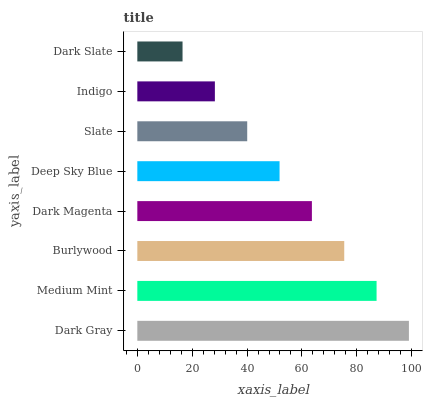Is Dark Slate the minimum?
Answer yes or no. Yes. Is Dark Gray the maximum?
Answer yes or no. Yes. Is Medium Mint the minimum?
Answer yes or no. No. Is Medium Mint the maximum?
Answer yes or no. No. Is Dark Gray greater than Medium Mint?
Answer yes or no. Yes. Is Medium Mint less than Dark Gray?
Answer yes or no. Yes. Is Medium Mint greater than Dark Gray?
Answer yes or no. No. Is Dark Gray less than Medium Mint?
Answer yes or no. No. Is Dark Magenta the high median?
Answer yes or no. Yes. Is Deep Sky Blue the low median?
Answer yes or no. Yes. Is Indigo the high median?
Answer yes or no. No. Is Medium Mint the low median?
Answer yes or no. No. 